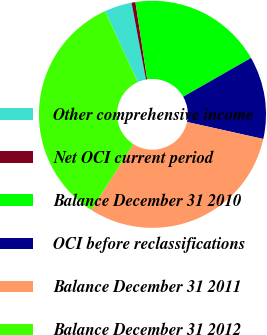<chart> <loc_0><loc_0><loc_500><loc_500><pie_chart><fcel>Other comprehensive income<fcel>Net OCI current period<fcel>Balance December 31 2010<fcel>OCI before reclassifications<fcel>Balance December 31 2011<fcel>Balance December 31 2012<nl><fcel>3.9%<fcel>0.55%<fcel>19.13%<fcel>11.75%<fcel>30.57%<fcel>34.09%<nl></chart> 